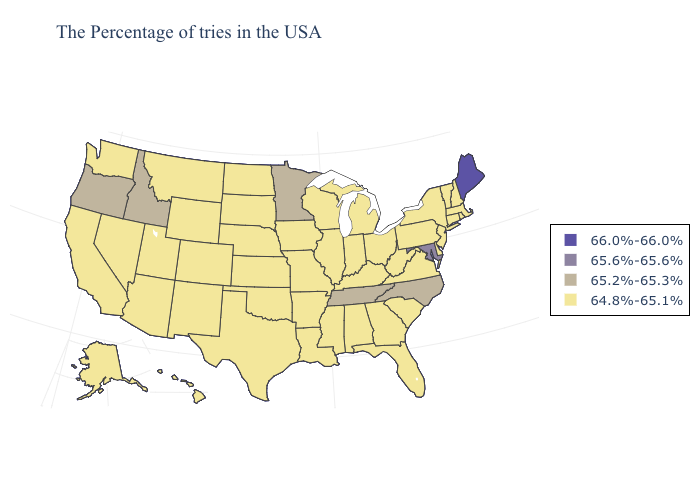What is the lowest value in the Northeast?
Keep it brief. 64.8%-65.1%. What is the value of New Jersey?
Be succinct. 64.8%-65.1%. Among the states that border Idaho , does Wyoming have the highest value?
Write a very short answer. No. Name the states that have a value in the range 66.0%-66.0%?
Give a very brief answer. Maine. Does Minnesota have the lowest value in the MidWest?
Give a very brief answer. No. What is the value of Ohio?
Answer briefly. 64.8%-65.1%. Name the states that have a value in the range 64.8%-65.1%?
Be succinct. Massachusetts, Rhode Island, New Hampshire, Vermont, Connecticut, New York, New Jersey, Delaware, Pennsylvania, Virginia, South Carolina, West Virginia, Ohio, Florida, Georgia, Michigan, Kentucky, Indiana, Alabama, Wisconsin, Illinois, Mississippi, Louisiana, Missouri, Arkansas, Iowa, Kansas, Nebraska, Oklahoma, Texas, South Dakota, North Dakota, Wyoming, Colorado, New Mexico, Utah, Montana, Arizona, Nevada, California, Washington, Alaska, Hawaii. What is the highest value in states that border Utah?
Be succinct. 65.2%-65.3%. Name the states that have a value in the range 65.6%-65.6%?
Answer briefly. Maryland. Which states have the lowest value in the USA?
Keep it brief. Massachusetts, Rhode Island, New Hampshire, Vermont, Connecticut, New York, New Jersey, Delaware, Pennsylvania, Virginia, South Carolina, West Virginia, Ohio, Florida, Georgia, Michigan, Kentucky, Indiana, Alabama, Wisconsin, Illinois, Mississippi, Louisiana, Missouri, Arkansas, Iowa, Kansas, Nebraska, Oklahoma, Texas, South Dakota, North Dakota, Wyoming, Colorado, New Mexico, Utah, Montana, Arizona, Nevada, California, Washington, Alaska, Hawaii. What is the value of Washington?
Be succinct. 64.8%-65.1%. Name the states that have a value in the range 65.2%-65.3%?
Answer briefly. North Carolina, Tennessee, Minnesota, Idaho, Oregon. What is the highest value in the West ?
Keep it brief. 65.2%-65.3%. 